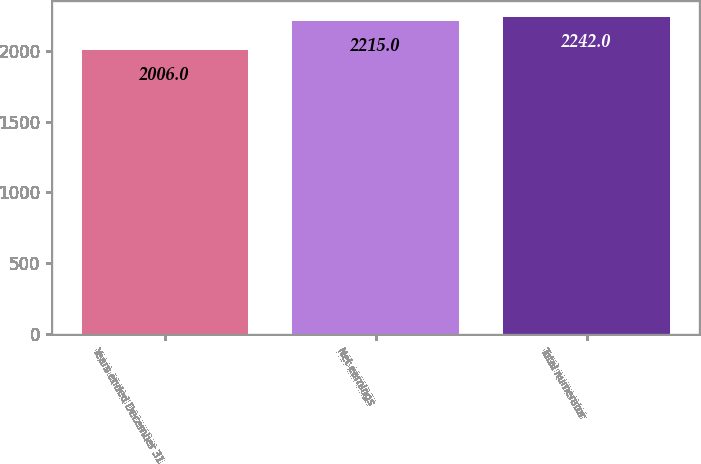Convert chart to OTSL. <chart><loc_0><loc_0><loc_500><loc_500><bar_chart><fcel>Years ended December 31<fcel>Net earnings<fcel>Total numerator<nl><fcel>2006<fcel>2215<fcel>2242<nl></chart> 